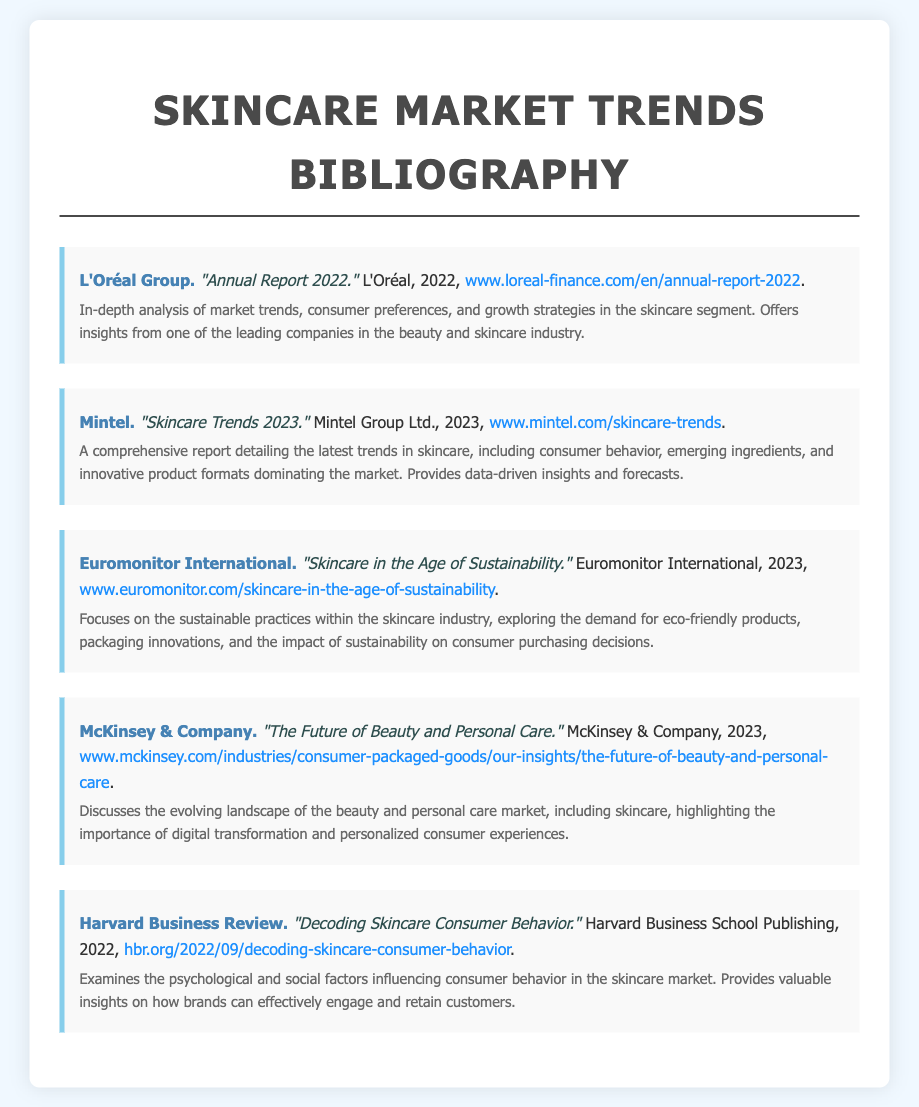What is the title of L'Oréal's report? The title of L'Oréal's report is provided in the entry, which is "Annual Report 2022."
Answer: "Annual Report 2022." Who published the "Skincare Trends 2023" report? The entry notes that Mintel is the publisher of the report titled "Skincare Trends 2023."
Answer: Mintel What year was the "Skincare in the Age of Sustainability" report published? The document specifies that Euromonitor International published the report in the year 2023.
Answer: 2023 Which company discusses digital transformation in their report? McKinsey & Company discusses digital transformation in the report titled "The Future of Beauty and Personal Care."
Answer: McKinsey & Company What is the main focus of the report by Euromonitor International? The entry describes the main focus of the report as sustainable practices within the skincare industry.
Answer: Sustainable practices What insights does the Harvard Business Review report provide? The entry states that the report examines the psychological and social factors influencing consumer behavior.
Answer: Psychological and social factors How many reports were published in 2023? The document lists three reports that were published in the year 2023.
Answer: Three Who authored the report "Decoding Skincare Consumer Behavior"? The document indicates that Harvard Business Review authored the report titled "Decoding Skincare Consumer Behavior."
Answer: Harvard Business Review What is a key theme in the report by McKinsey & Company? The key theme mentioned in the overview of McKinsey & Company's report is personalized consumer experiences.
Answer: Personalized consumer experiences 